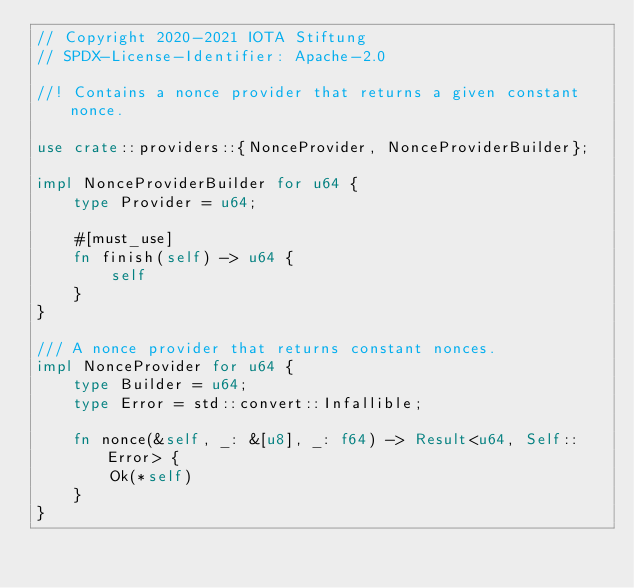<code> <loc_0><loc_0><loc_500><loc_500><_Rust_>// Copyright 2020-2021 IOTA Stiftung
// SPDX-License-Identifier: Apache-2.0

//! Contains a nonce provider that returns a given constant nonce.

use crate::providers::{NonceProvider, NonceProviderBuilder};

impl NonceProviderBuilder for u64 {
    type Provider = u64;

    #[must_use]
    fn finish(self) -> u64 {
        self
    }
}

/// A nonce provider that returns constant nonces.
impl NonceProvider for u64 {
    type Builder = u64;
    type Error = std::convert::Infallible;

    fn nonce(&self, _: &[u8], _: f64) -> Result<u64, Self::Error> {
        Ok(*self)
    }
}
</code> 